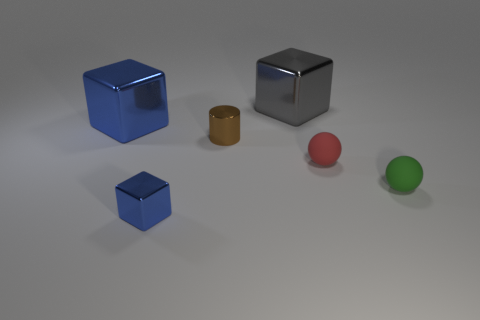Subtract all brown cylinders. How many blue blocks are left? 2 Add 3 gray shiny objects. How many objects exist? 9 Subtract all large metallic blocks. How many blocks are left? 1 Subtract all cylinders. How many objects are left? 5 Add 5 yellow spheres. How many yellow spheres exist? 5 Subtract 0 brown balls. How many objects are left? 6 Subtract all small cubes. Subtract all tiny objects. How many objects are left? 1 Add 2 tiny red spheres. How many tiny red spheres are left? 3 